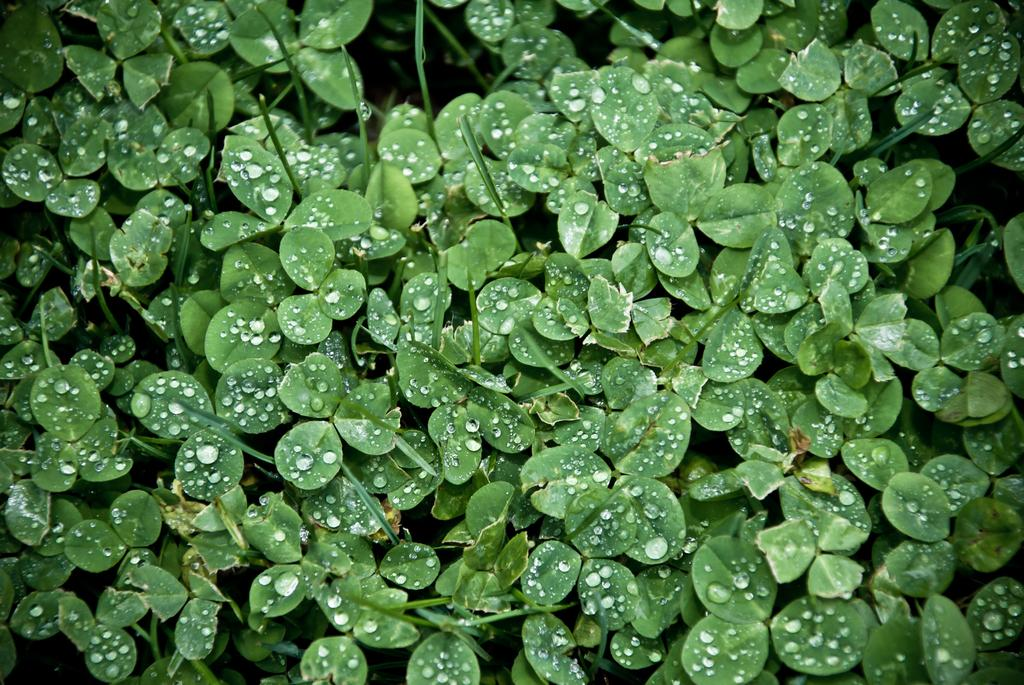What type of plant material is present in the image? The image contains leaves of plants. Can you describe the condition of the leaves? There are water drops on the leaves. What type of manager is responsible for the dust in the image? There is no manager or dust present in the image; it only contains leaves with water drops on them. 